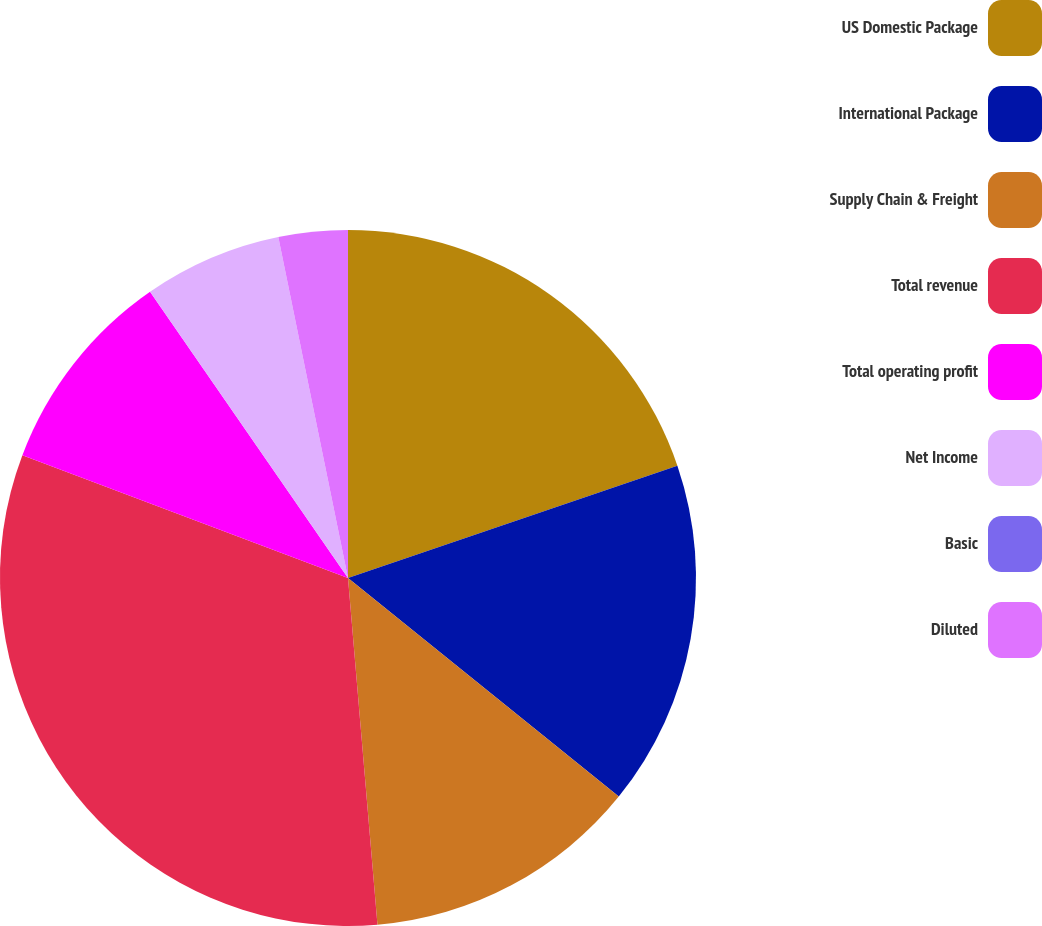Convert chart. <chart><loc_0><loc_0><loc_500><loc_500><pie_chart><fcel>US Domestic Package<fcel>International Package<fcel>Supply Chain & Freight<fcel>Total revenue<fcel>Total operating profit<fcel>Net Income<fcel>Basic<fcel>Diluted<nl><fcel>19.77%<fcel>16.04%<fcel>12.84%<fcel>32.09%<fcel>9.63%<fcel>6.42%<fcel>0.0%<fcel>3.21%<nl></chart> 